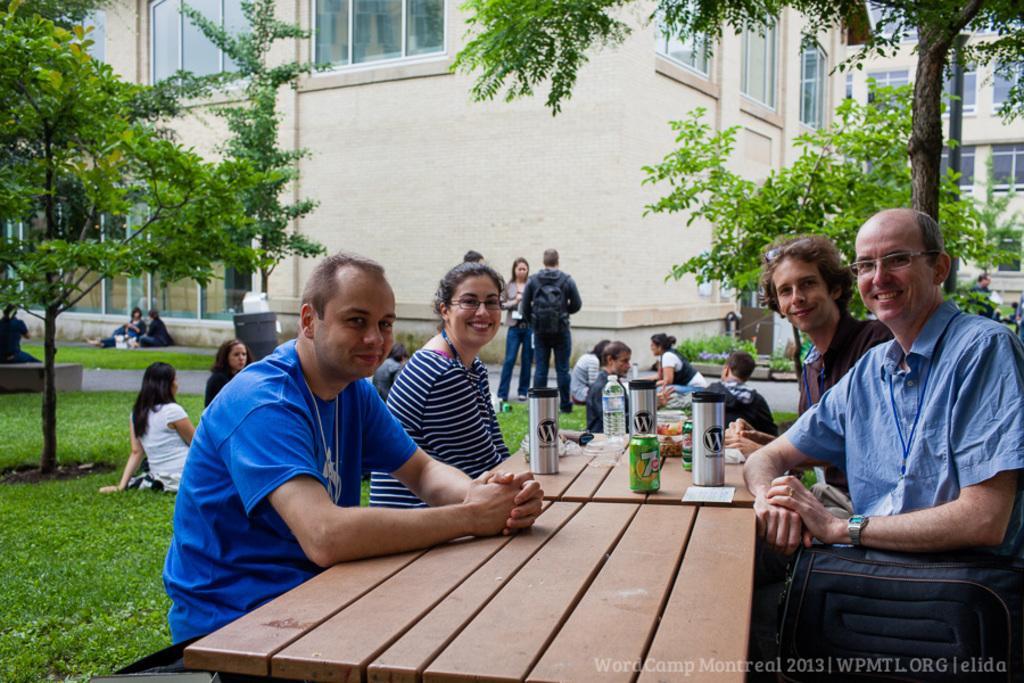Describe this image in one or two sentences. This is the picture of the outside which is a Garden area which includes Trees, Grass, Tables and Benches. There are some bottles and a can which is placed on the top of the table. At the right corner there are two men sitting on the bench and smiling. At left there is a Man and Woman sitting on the bench and smiling. At the center there is a group of people sitting and seems to be talking and there is a Man wearing a Backpack and standing in a group of people. At the top left there are two persons sitting on the ground. We can see the building in the background. 